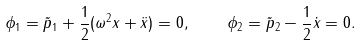Convert formula to latex. <formula><loc_0><loc_0><loc_500><loc_500>\phi _ { 1 } = \tilde { p } _ { 1 } + \frac { 1 } { 2 } ( \omega ^ { 2 } x + \ddot { x } ) = 0 , \quad \phi _ { 2 } = \tilde { p } _ { 2 } - \frac { 1 } { 2 } \dot { x } = 0 .</formula> 